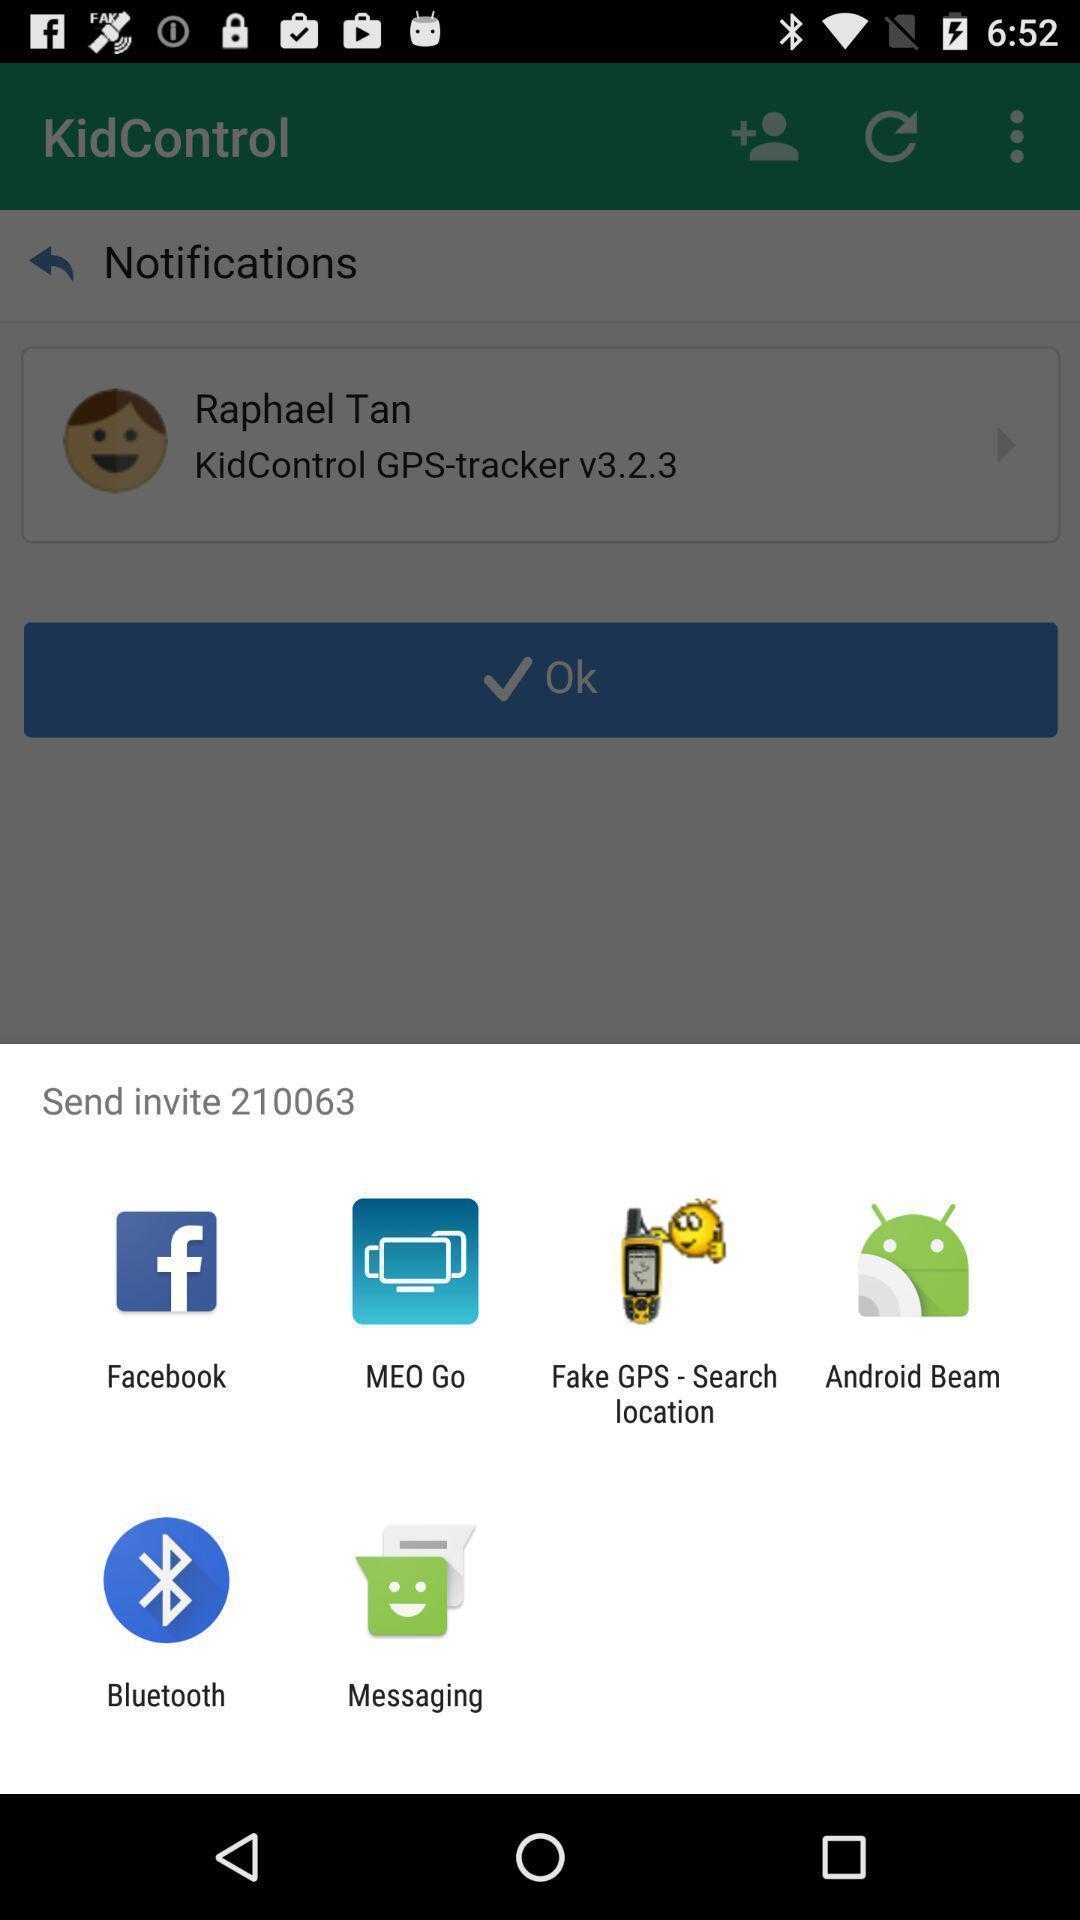Describe the key features of this screenshot. Pop-up is having different data sharing apps and social apps. 